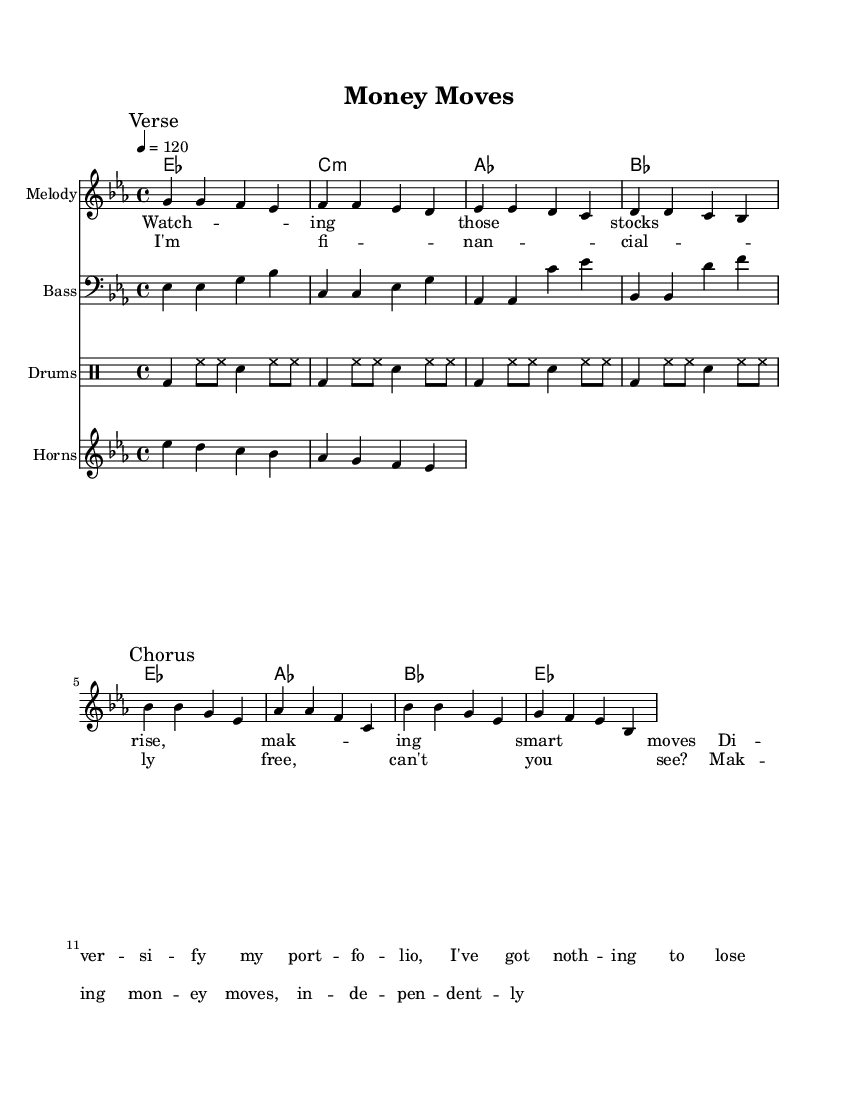What is the key signature of this music? The key signature is indicated at the beginning of the score. In this case, it is E-flat major, which features three flats (B-flat, E-flat, and A-flat).
Answer: E-flat major What is the time signature of this music? The time signature is usually located at the start of the score right after the key signature. Here, it is 4/4, indicating four beats per measure with each quarter note getting one beat.
Answer: 4/4 What is the tempo marking of this music? The tempo is given in beats per minute and is located above the staff. The marking here indicates a tempo of 120 beats per minute.
Answer: 120 How many measures are in the verse section? To find the number of measures in the verse, we count the number of measures from the start of the "Verse" marking to the end of that section, which totals four measures.
Answer: Four measures Which part features lyrics about financial independence? The chorus section highlights lyrics related to financial independence, specifically in the lines sung after the "Chorus" marking.
Answer: Chorus What instruments are included in this score? The instruments mentioned are shown at the beginning of their respective staves. In this score, there are Melody, Bass, Drums, and Horns.
Answer: Melody, Bass, Drums, Horns What is the rhythmic pattern of the drums in this song? The rhythms for drums are specified in the drummode section. The pattern consists of bass drums played on the first beat followed by hi-hat and snare combinations in an alternating fashion, consistent across four measures.
Answer: Bass and hi-hat 